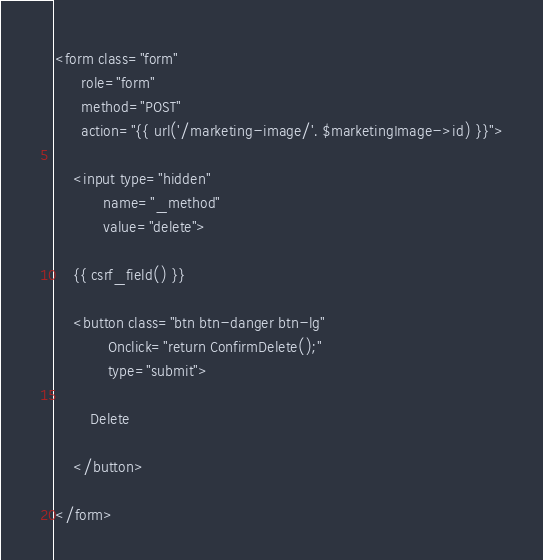<code> <loc_0><loc_0><loc_500><loc_500><_PHP_><form class="form"
      role="form"
      method="POST"
      action="{{ url('/marketing-image/'. $marketingImage->id) }}">

    <input type="hidden"
           name="_method"
           value="delete">

    {{ csrf_field() }}

    <button class="btn btn-danger btn-lg"
            Onclick="return ConfirmDelete();"
            type="submit">

        Delete

    </button>

</form></code> 